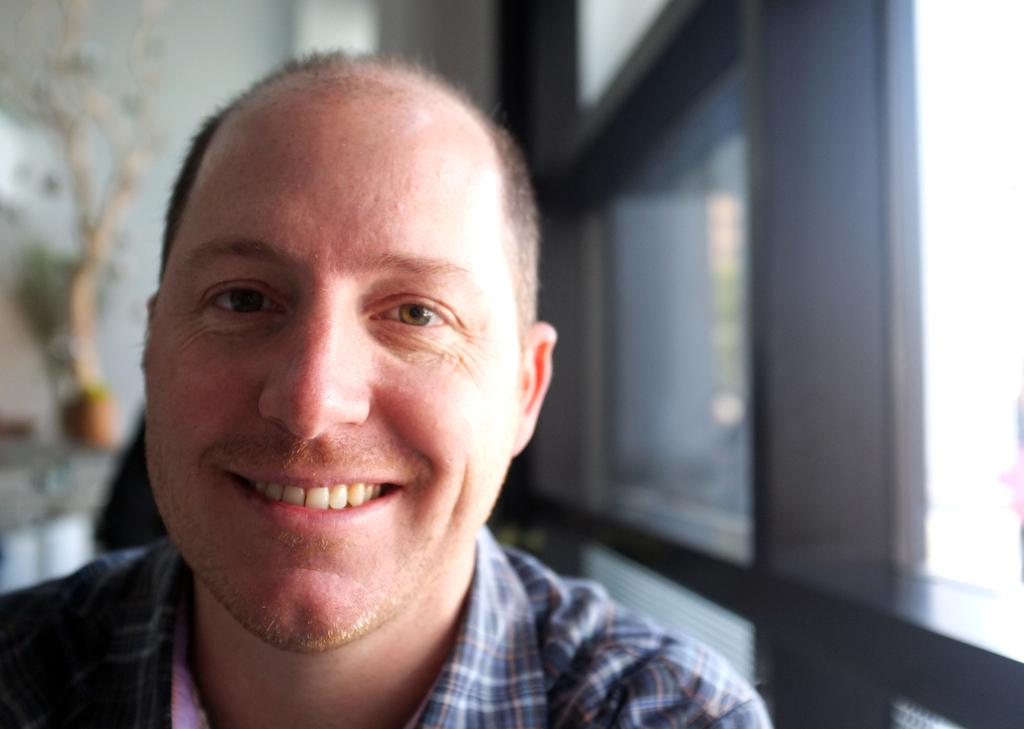Who is the main subject in the foreground of the picture? There is a man in the foreground of the picture. What is the man's facial expression in the image? The man is smiling in the image. What can be seen on the right side of the picture? There is a window on the right side of the picture. How would you describe the background of the image? The background of the image is blurred. What type of dogs can be seen in the image, and what do they smell? There are no dogs present in the image, and therefore no smells can be attributed to them. 